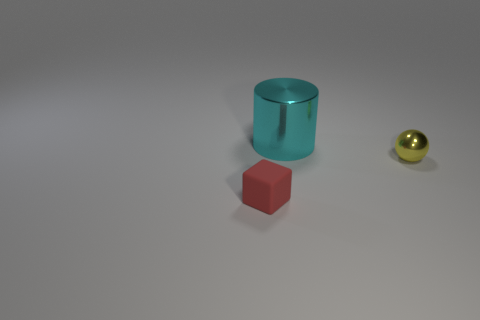Subtract all purple balls. Subtract all brown blocks. How many balls are left? 1 Add 2 large cyan metallic cylinders. How many objects exist? 5 Subtract all cylinders. How many objects are left? 2 Add 3 large gray shiny balls. How many large gray shiny balls exist? 3 Subtract 1 red blocks. How many objects are left? 2 Subtract all metallic spheres. Subtract all large shiny cylinders. How many objects are left? 1 Add 3 matte objects. How many matte objects are left? 4 